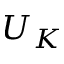<formula> <loc_0><loc_0><loc_500><loc_500>U _ { K }</formula> 